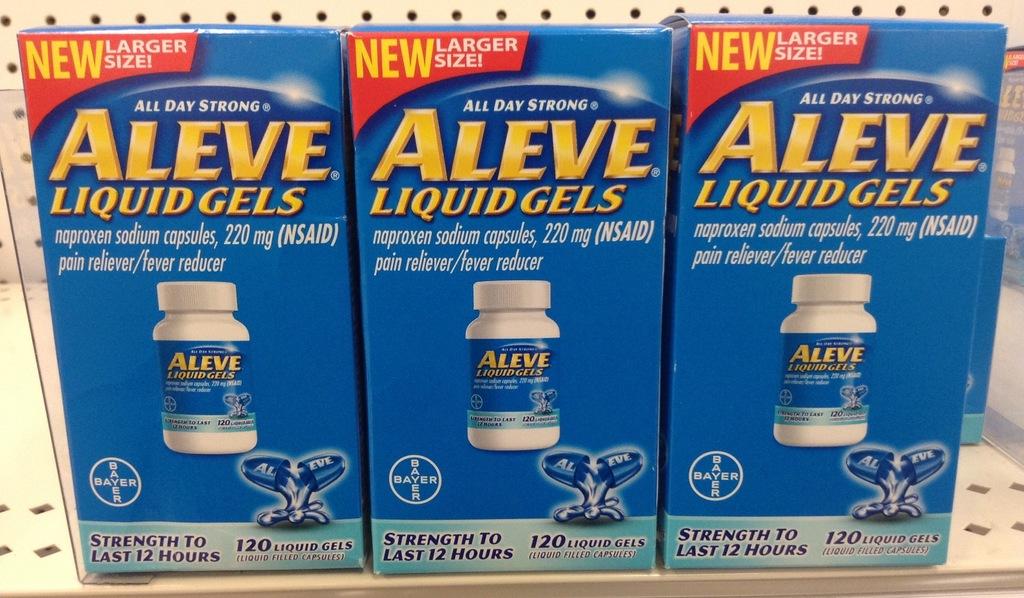How long does the box claim that these gels last?
Offer a terse response. 12 hours. How many liquid gels come in a box?
Ensure brevity in your answer.  120. 